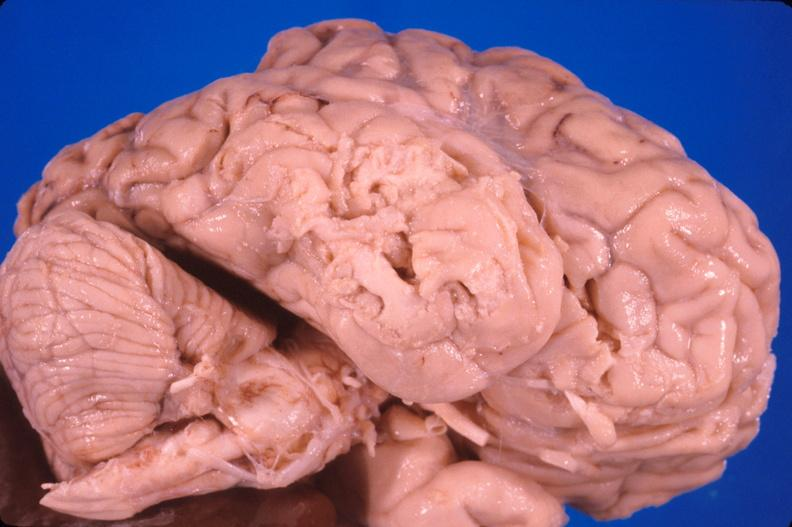does papillary astrocytoma show brain, old infarcts, embolic?
Answer the question using a single word or phrase. No 